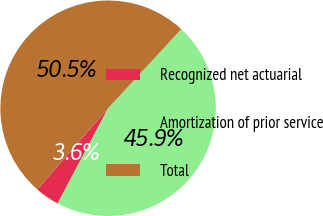Convert chart. <chart><loc_0><loc_0><loc_500><loc_500><pie_chart><fcel>Recognized net actuarial<fcel>Amortization of prior service<fcel>Total<nl><fcel>3.64%<fcel>45.88%<fcel>50.47%<nl></chart> 